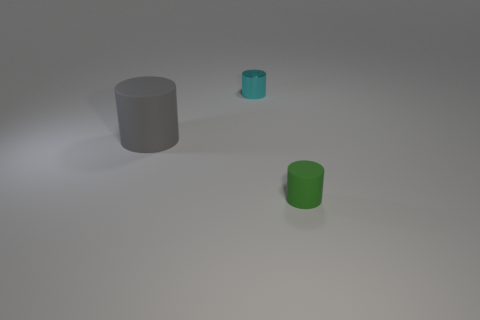How many objects are there and can you describe their arrangement? There are three objects in the scene. From left to right, we have a gray cylinder, a smaller cyan cylinder, and a green cylinder, each placed at a distance from one another on a flat surface. 